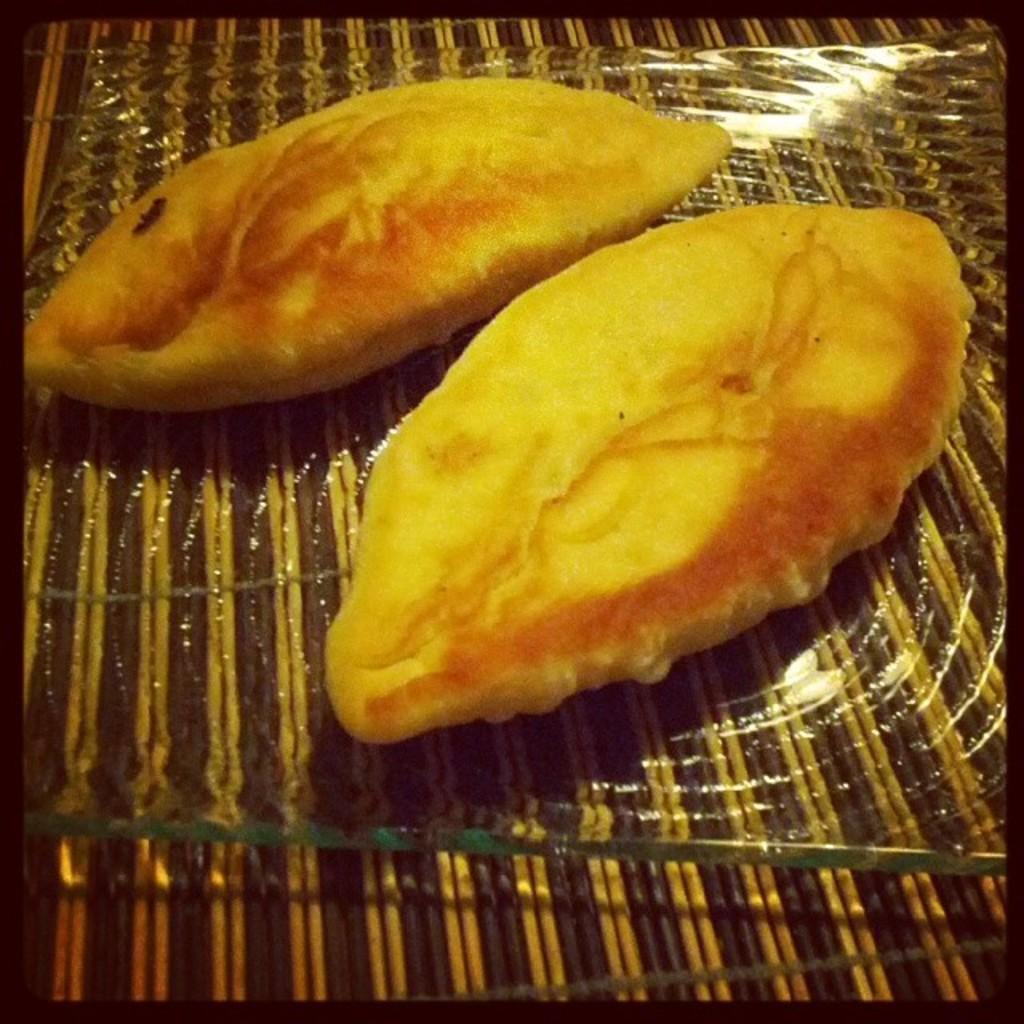Please provide a concise description of this image. In this image we can see the food items placed on the mat and the image has borders. 